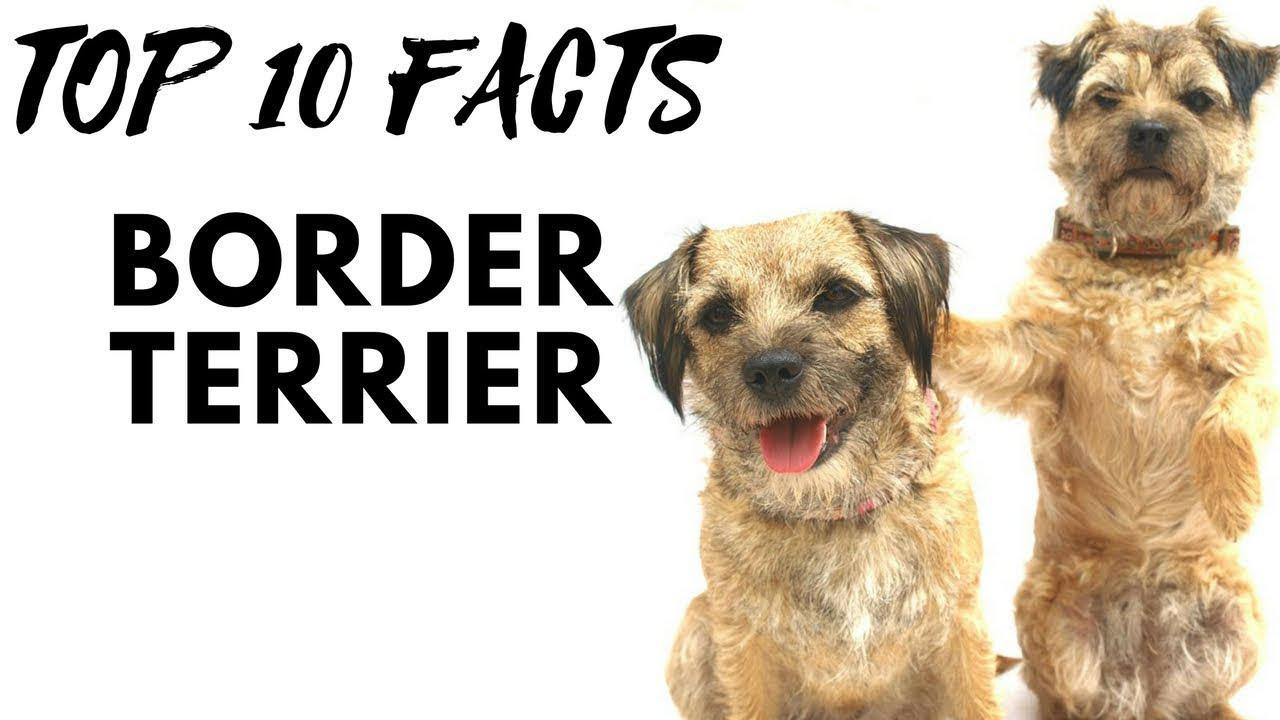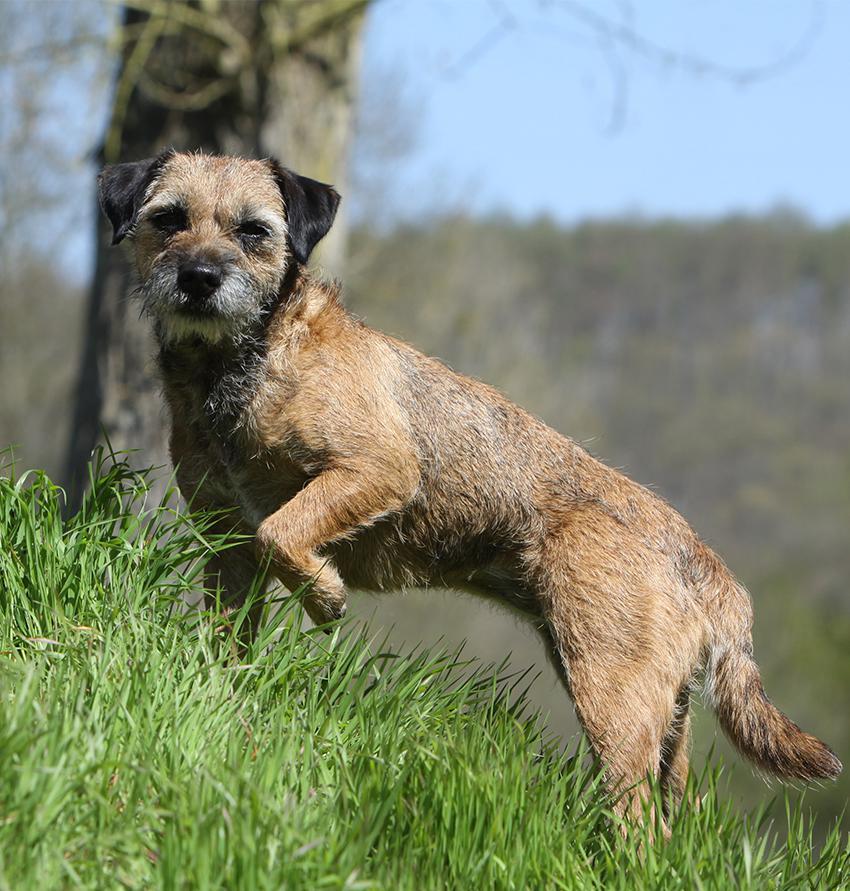The first image is the image on the left, the second image is the image on the right. Analyze the images presented: Is the assertion "The left and right image contains the same number of dogs with at least one of them sitting." valid? Answer yes or no. No. The first image is the image on the left, the second image is the image on the right. Evaluate the accuracy of this statement regarding the images: "A dog is laying down.". Is it true? Answer yes or no. No. 